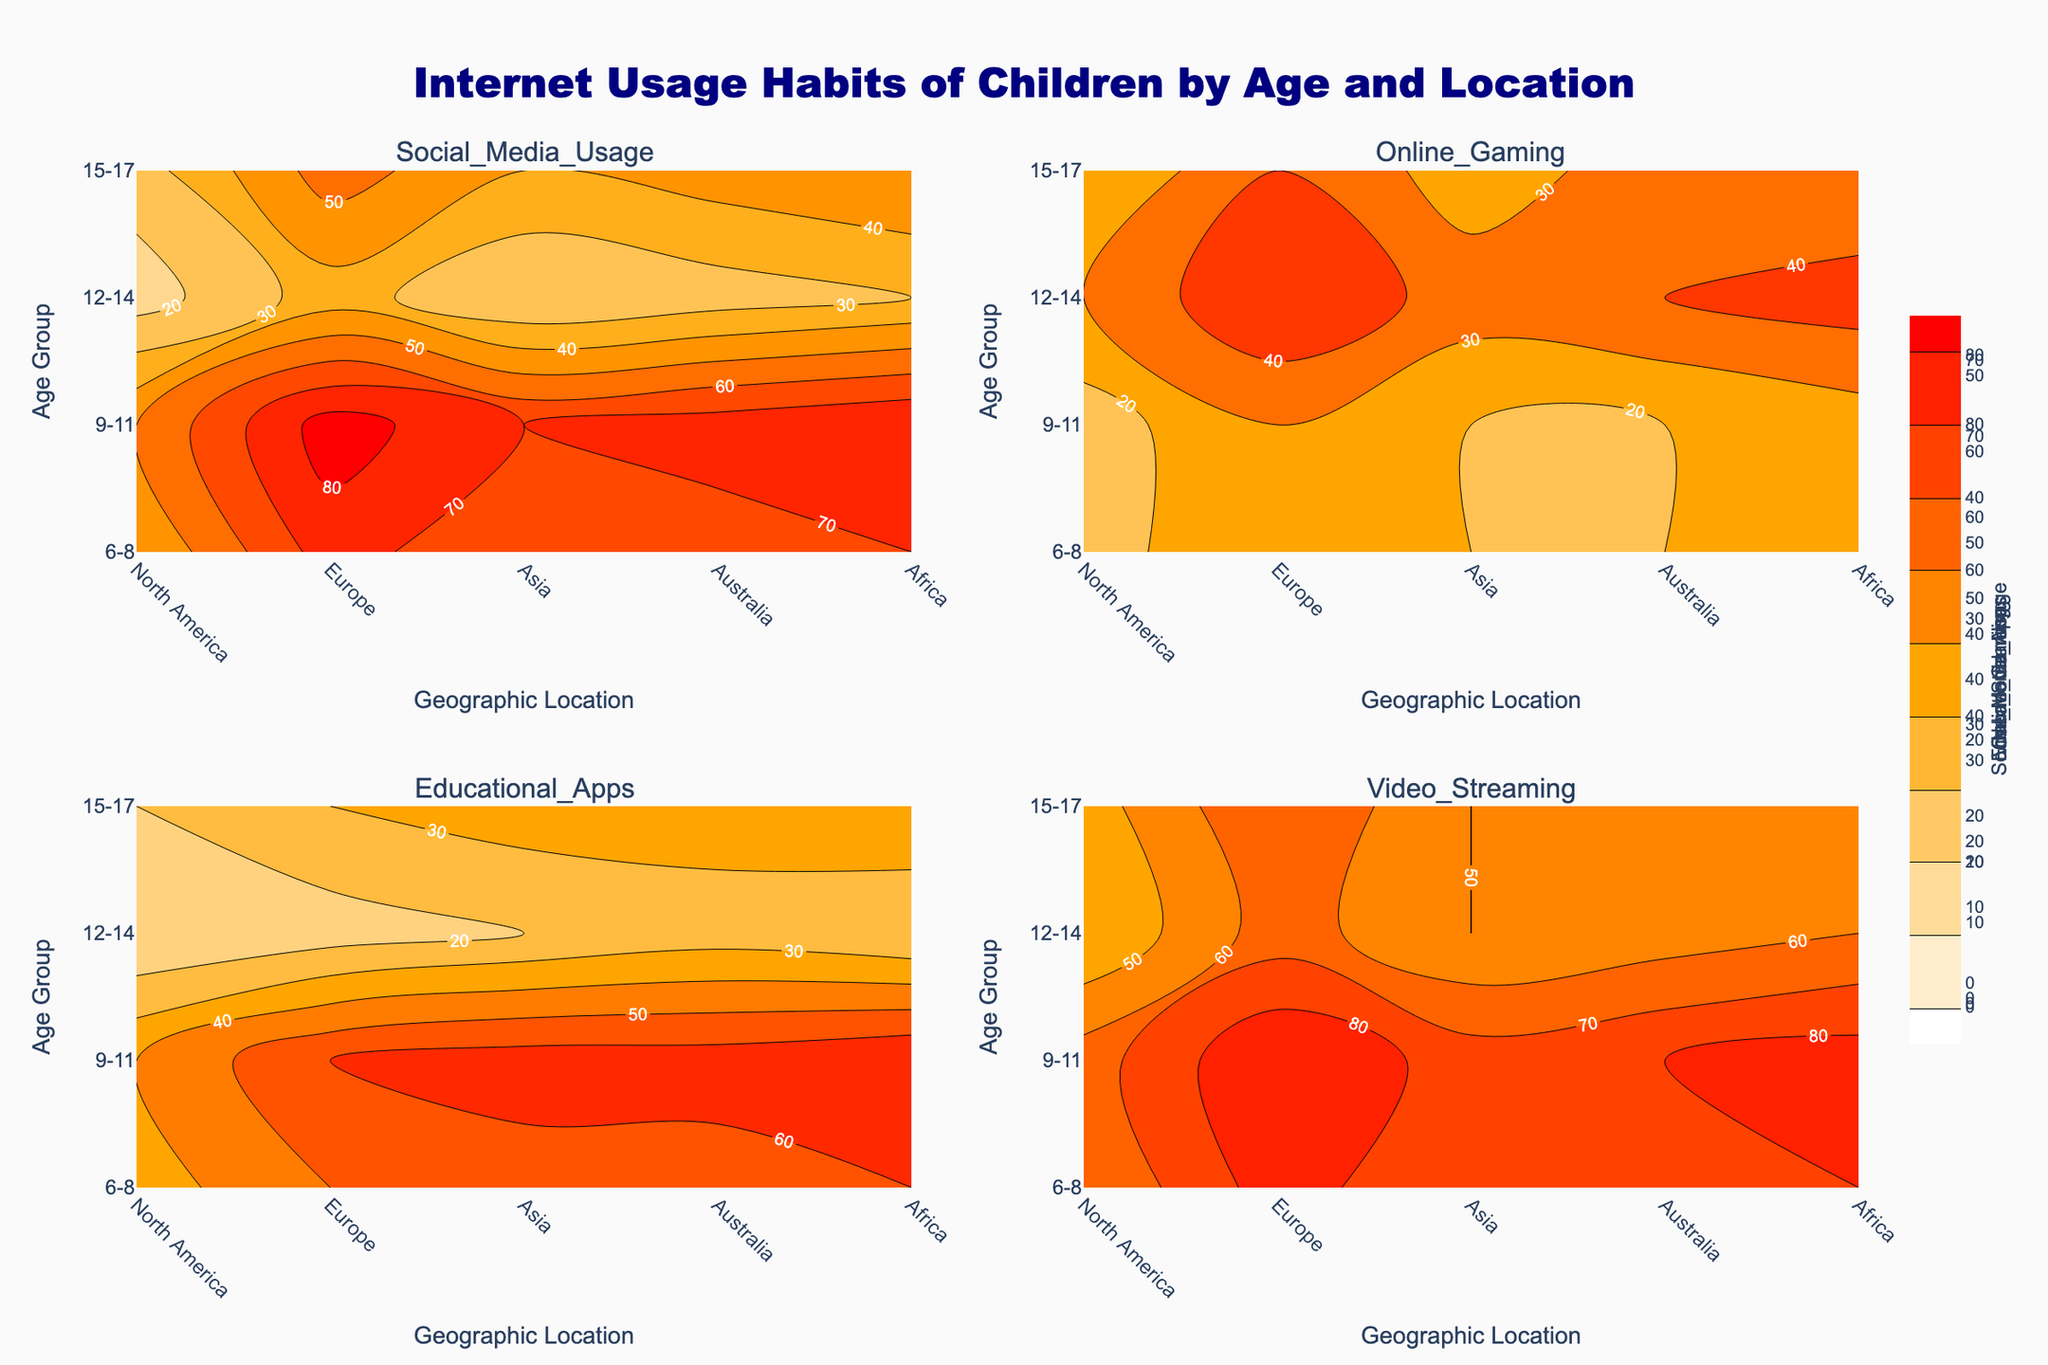What is the title of the plot? The title of the plot is typically positioned at the top center of the figure. Reading the title directly from this part helps understand the overall topic of the plot.
Answer: Internet Usage Habits of Children by Age and Location Which age group and geographic location show the highest usage for social media? Identify the category of 'Social Media Usage' on the plot, then find the darkest contour which represents the highest value. Trace this back to the respective age group and geographic location.
Answer: 15-17 in Asia In which geographic location do 12-14-year-olds use the most educational apps? On the subplot for 'Educational Apps', identify the contour levels and find the highest value for the age group 12-14. Then trace it to the corresponding geographic location.
Answer: North America Across all age groups, which region has the lowest overall online gaming usage? For the 'Online Gaming' subplot, observe the contour for consistently lighter shades indicating lower values. Compare across all age groups to determine the geographic location with the consistently lowest values.
Answer: Africa Which age group in Europe has the highest total internet usage? Although 'Total Usage' is not directly depicted, use the majority trends in individual categories (like highest video streaming, social media, etc.) indicated by darker contour levels, then reason through the combined impact. Refer to values in the table for precise calculation.
Answer: 15-17 How does video streaming usage in North America for 6-8-year-olds compare to 9-11-year-olds? Check the 'Video Streaming' subplot, compare the contour levels for the age groups 6-8 and 9-11 within the North American region. Determine which contour is darker/brighter or trace back to see the actual values if available through contours.
Answer: It is the same (60) Which is higher: social media usage in Asia for ages 9-11 or video streaming in Europe for the same age group? Spot the respective contours in each of the subplots and compare their levels. Determine which contour is darker/brighter to conclude the higher value or cross-check the exact values.
Answer: Social Media Usage in Asia for ages 9-11 What can you infer about the trend in social media usage as children age in North America? Observe all the age groups within the 'Social Media Usage' subplot specifically under North America. Look for increasing or decreasing contour shades, representing values as the age progresses.
Answer: It increases In the subplot for online gaming, where do you see the most significant usage discrepancy between consecutive age groups in Africa? In the 'Online Gaming' subplot, look for the largest contrast in contour shading between consecutive age groups for Africa. Identify the specific transition period.
Answer: Between 9-11 and 12-14 Which category shows the highest usage discrepancy between North America and Africa for the age group 12-14? Compare the contours for 12-14-year-olds between North America and Africa across all subplots. The subplot with the greatest difference in contour shade represents the highest usage discrepancy.
Answer: Social Media Usage 